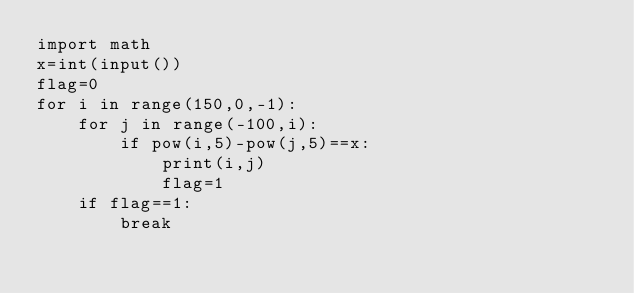<code> <loc_0><loc_0><loc_500><loc_500><_Python_>import math
x=int(input())
flag=0
for i in range(150,0,-1):
    for j in range(-100,i):
        if pow(i,5)-pow(j,5)==x:
            print(i,j)
            flag=1
    if flag==1:
        break</code> 